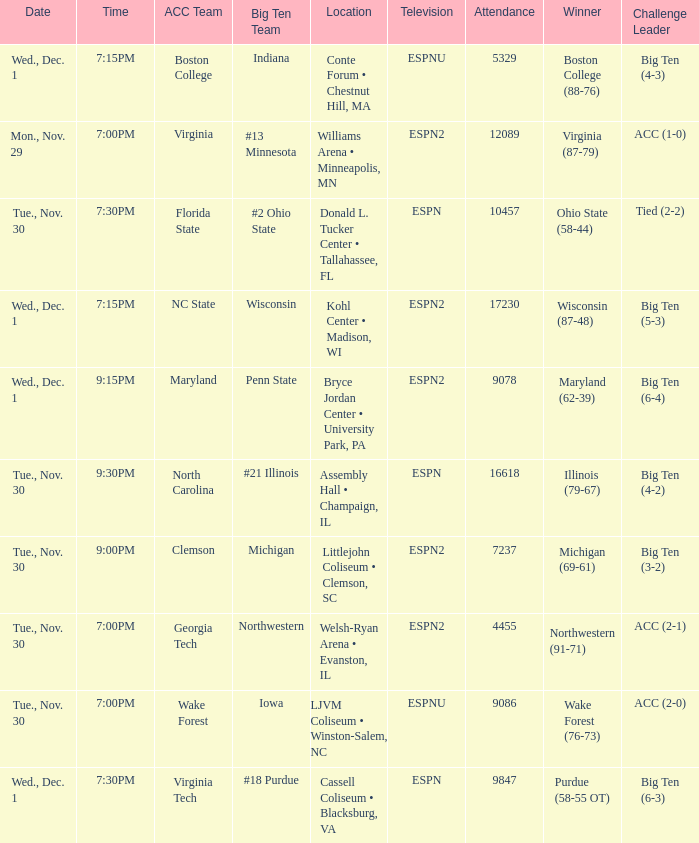Who were the challenge leaders of the games won by boston college (88-76)? Big Ten (4-3). 